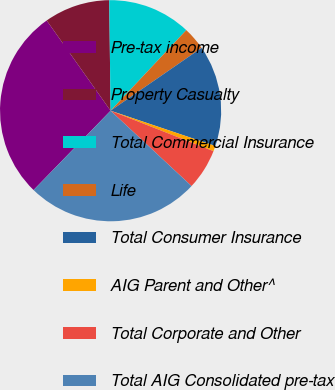Convert chart to OTSL. <chart><loc_0><loc_0><loc_500><loc_500><pie_chart><fcel>Pre-tax income<fcel>Property Casualty<fcel>Total Commercial Insurance<fcel>Life<fcel>Total Consumer Insurance<fcel>AIG Parent and Other^<fcel>Total Corporate and Other<fcel>Total AIG Consolidated pre-tax<nl><fcel>27.93%<fcel>9.61%<fcel>12.2%<fcel>3.38%<fcel>14.79%<fcel>0.79%<fcel>5.97%<fcel>25.34%<nl></chart> 